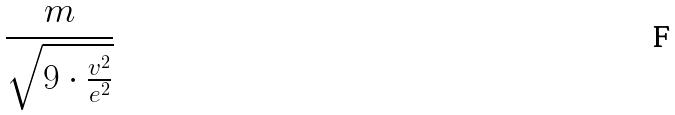Convert formula to latex. <formula><loc_0><loc_0><loc_500><loc_500>\frac { m } { \sqrt { 9 \cdot \frac { v ^ { 2 } } { e ^ { 2 } } } }</formula> 